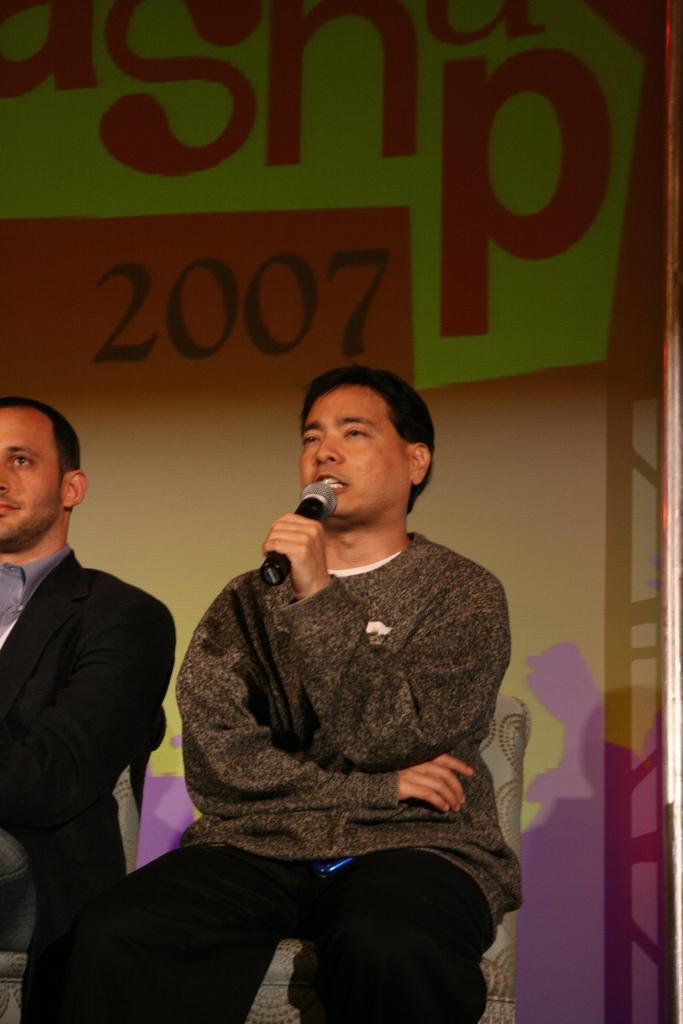Describe this image in one or two sentences. In this image, we can see a man sitting and he is holding a microphone, he is speaking in the microphone, at the left side there is a man sitting on the chair, in the background we can see a poster. 